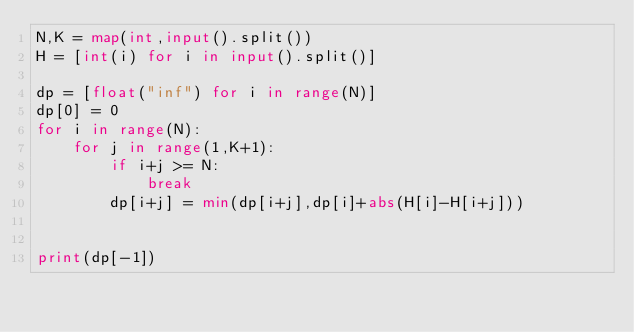<code> <loc_0><loc_0><loc_500><loc_500><_Python_>N,K = map(int,input().split())
H = [int(i) for i in input().split()]

dp = [float("inf") for i in range(N)]
dp[0] = 0
for i in range(N):
    for j in range(1,K+1):
        if i+j >= N:
            break
        dp[i+j] = min(dp[i+j],dp[i]+abs(H[i]-H[i+j]))
    

print(dp[-1])</code> 